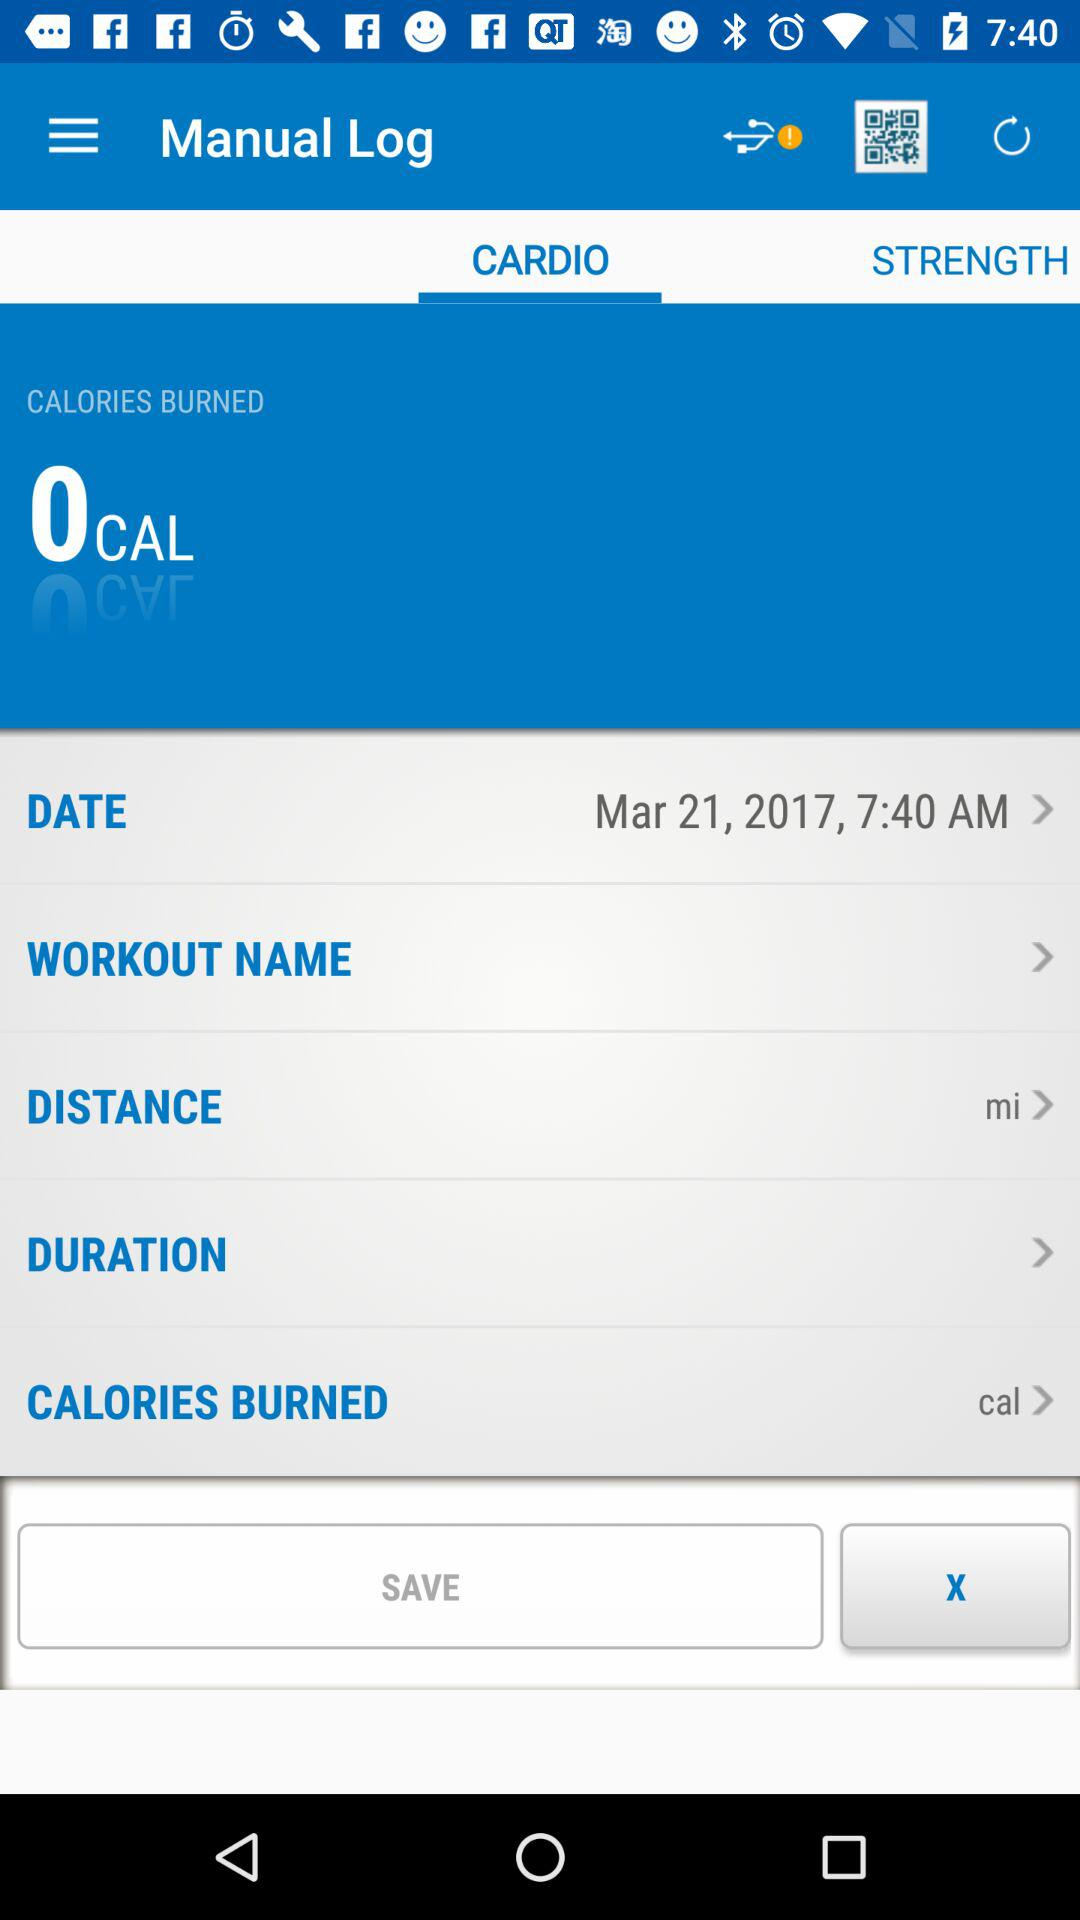How many total calories were burned in this workout?
Answer the question using a single word or phrase. 0 